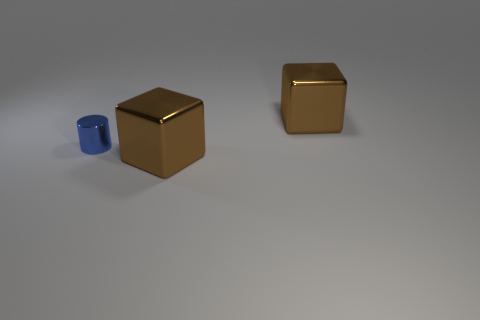The small cylinder has what color?
Your response must be concise. Blue. Is the shape of the big brown thing that is in front of the metal cylinder the same as  the blue metal object?
Ensure brevity in your answer.  No. How many objects are either large brown blocks behind the blue metallic object or small green metallic balls?
Provide a short and direct response. 1. Are there any large brown objects that have the same shape as the tiny metallic thing?
Provide a short and direct response. No. The brown thing that is in front of the big brown thing that is behind the big brown metal thing that is in front of the tiny blue shiny cylinder is what shape?
Provide a succinct answer. Cube. There is a tiny blue thing; is it the same shape as the large brown object that is behind the metal cylinder?
Your answer should be very brief. No. How many big objects are either blue metallic things or brown metal blocks?
Provide a succinct answer. 2. Are there any brown balls of the same size as the blue thing?
Give a very brief answer. No. There is a large shiny block that is to the left of the big thing behind the brown metal object that is in front of the small blue shiny cylinder; what is its color?
Ensure brevity in your answer.  Brown. Does the tiny cylinder have the same material as the big object in front of the small shiny object?
Offer a terse response. Yes. 